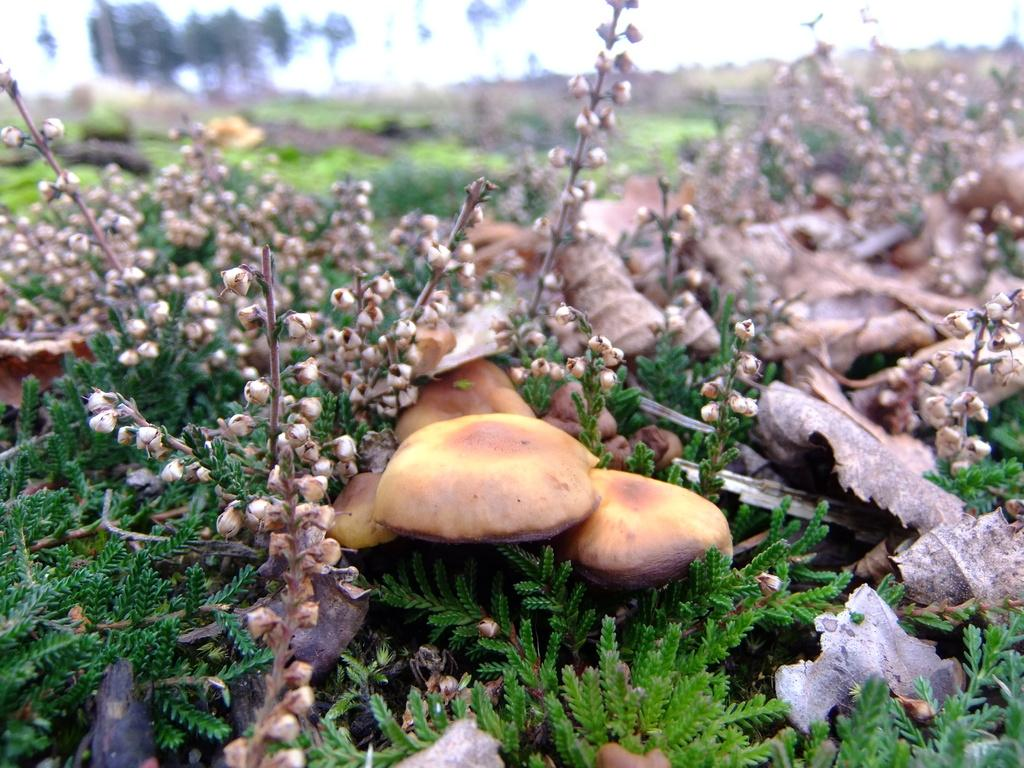What type of fungi can be seen on the ground in the image? There are mushrooms on the ground in the image. What other types of vegetation are present on the ground in the image? There are plants on the ground in the image. Can you describe the background of the image? The background of the image is blurred. What type of selection process is being used to choose the mushrooms in the image? There is no indication in the image that a selection process is being used to choose the mushrooms. 